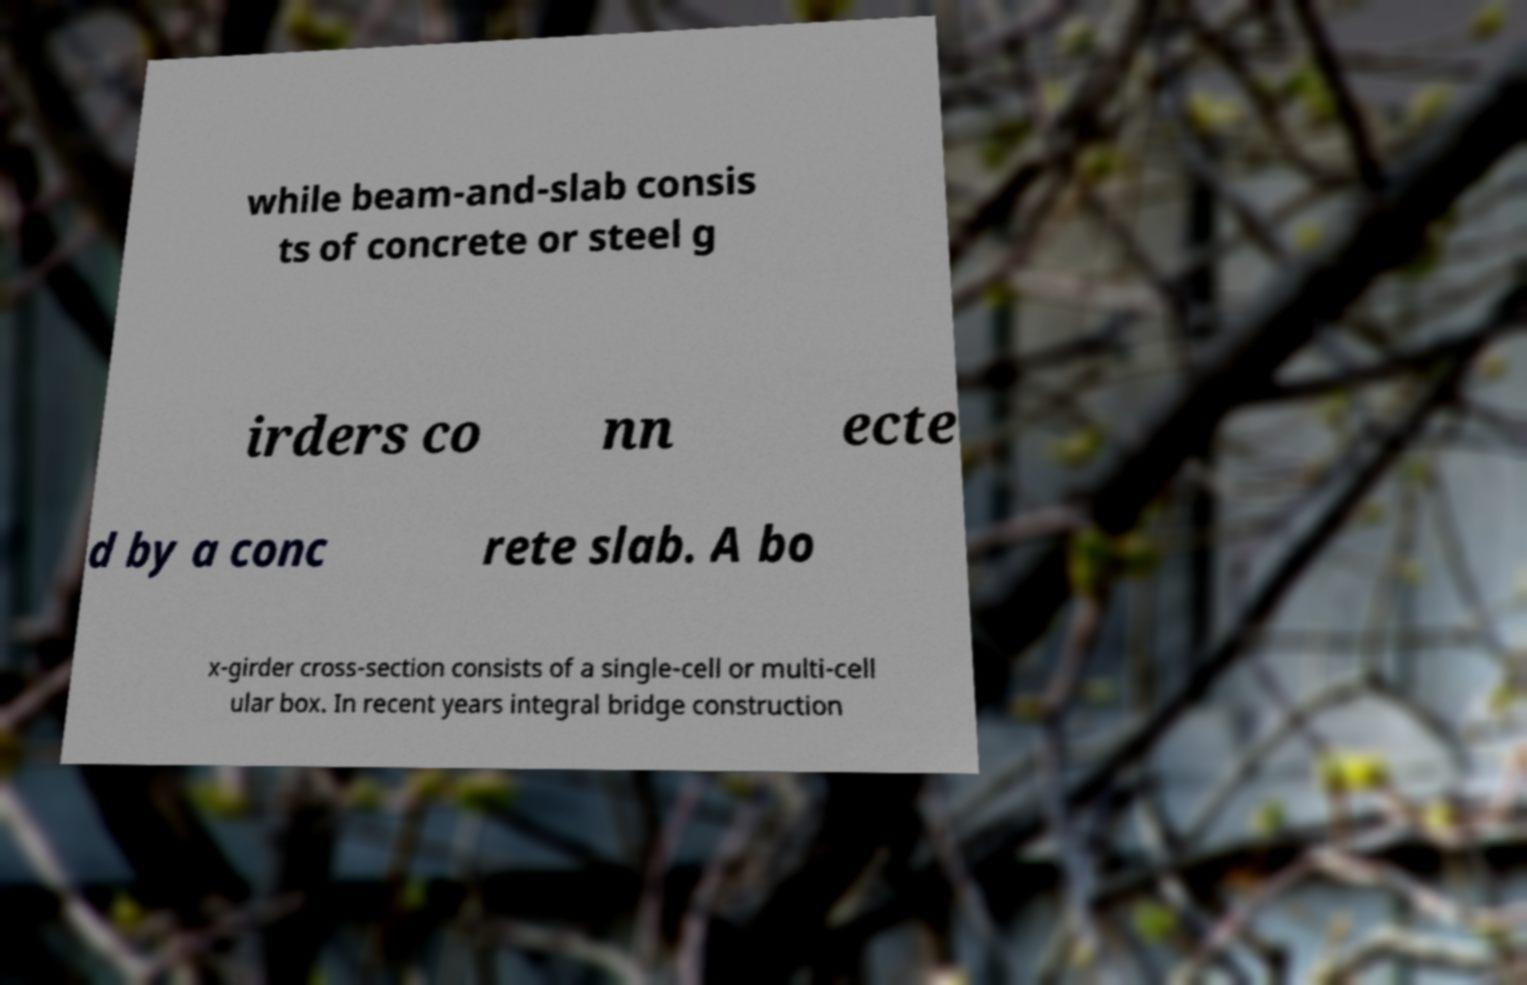Can you accurately transcribe the text from the provided image for me? while beam-and-slab consis ts of concrete or steel g irders co nn ecte d by a conc rete slab. A bo x-girder cross-section consists of a single-cell or multi-cell ular box. In recent years integral bridge construction 